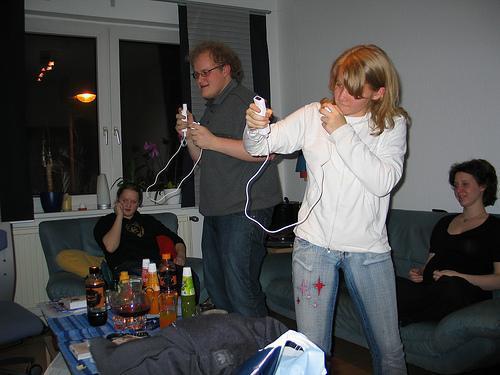How many people are in the picture?
Give a very brief answer. 4. 